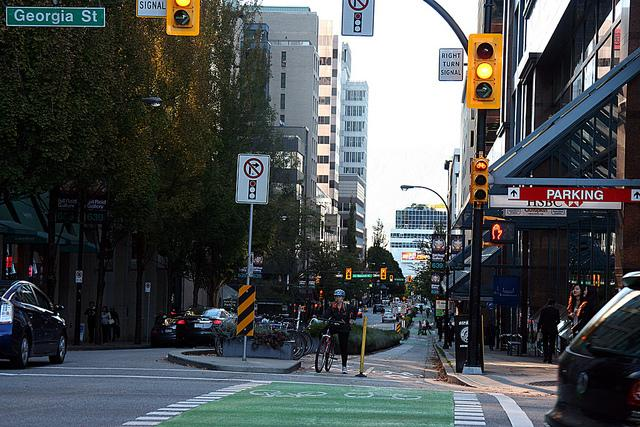What is the lane painted green for? crosswalk 